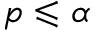Convert formula to latex. <formula><loc_0><loc_0><loc_500><loc_500>p \leqslant \alpha</formula> 